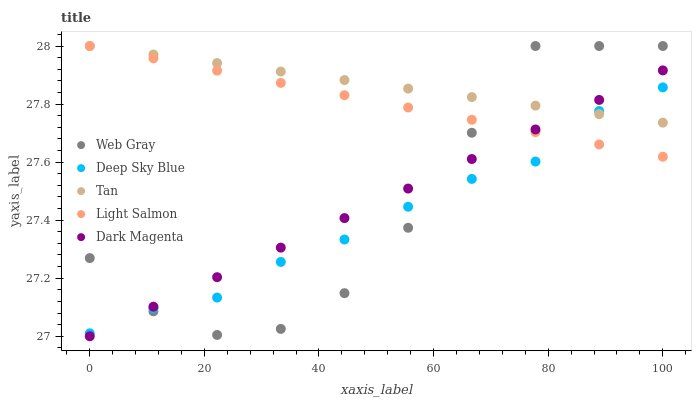Does Deep Sky Blue have the minimum area under the curve?
Answer yes or no. Yes. Does Tan have the maximum area under the curve?
Answer yes or no. Yes. Does Web Gray have the minimum area under the curve?
Answer yes or no. No. Does Web Gray have the maximum area under the curve?
Answer yes or no. No. Is Tan the smoothest?
Answer yes or no. Yes. Is Web Gray the roughest?
Answer yes or no. Yes. Is Light Salmon the smoothest?
Answer yes or no. No. Is Light Salmon the roughest?
Answer yes or no. No. Does Dark Magenta have the lowest value?
Answer yes or no. Yes. Does Web Gray have the lowest value?
Answer yes or no. No. Does Light Salmon have the highest value?
Answer yes or no. Yes. Does Deep Sky Blue have the highest value?
Answer yes or no. No. Does Web Gray intersect Dark Magenta?
Answer yes or no. Yes. Is Web Gray less than Dark Magenta?
Answer yes or no. No. Is Web Gray greater than Dark Magenta?
Answer yes or no. No. 